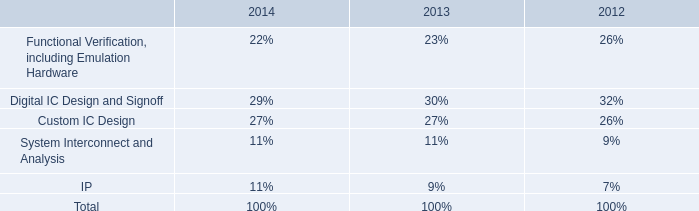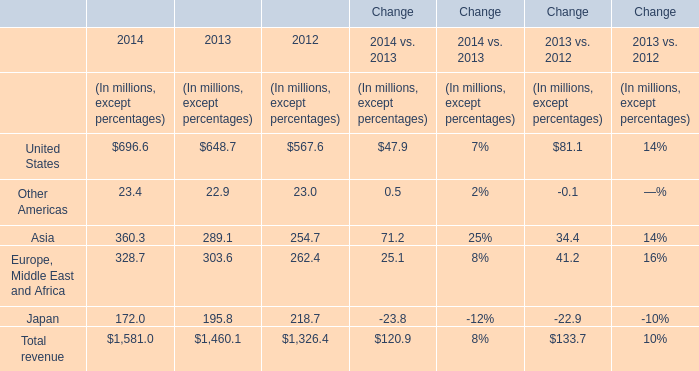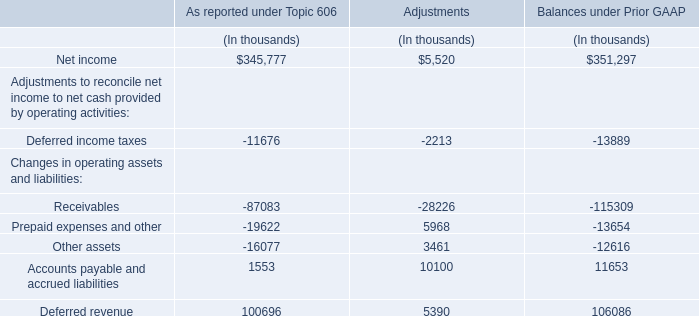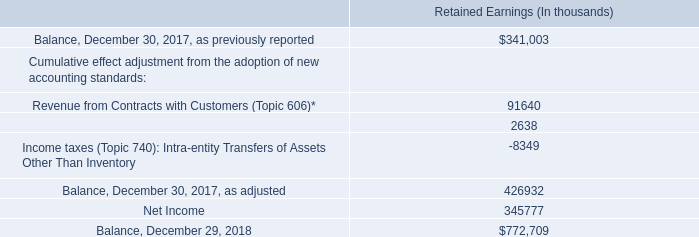How many years does United States stay higher than Other Americas? 
Answer: 3. 